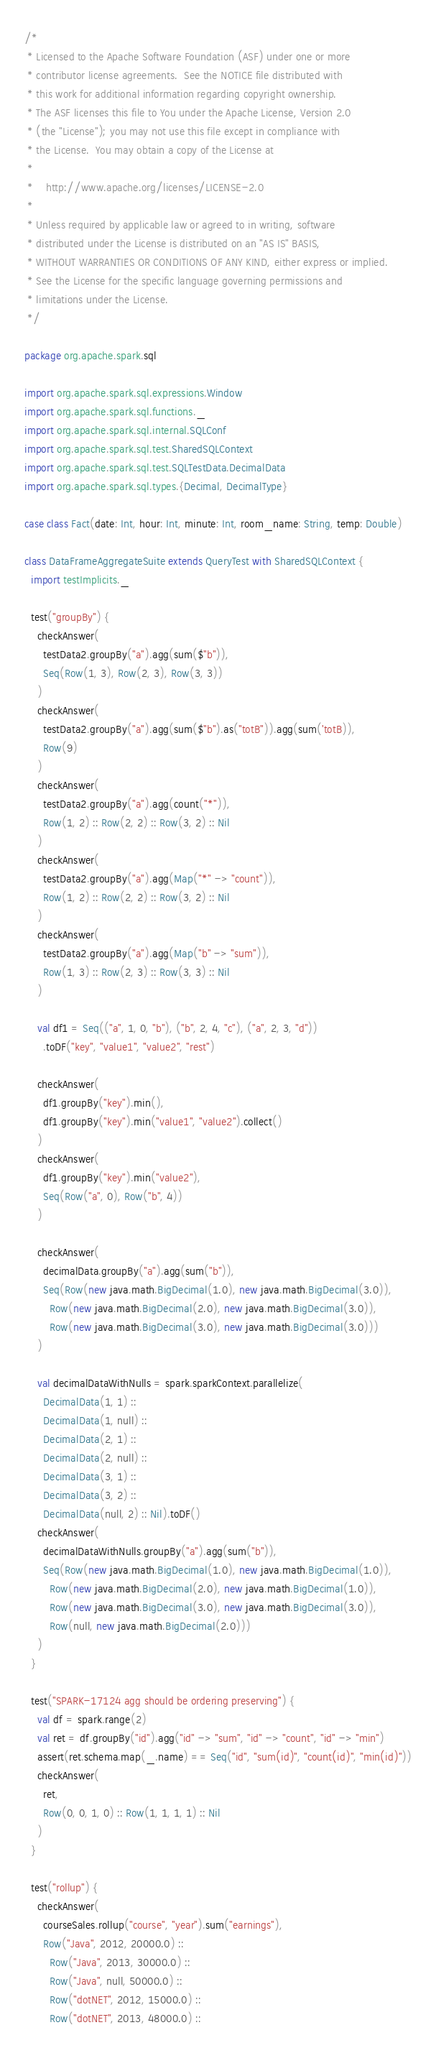<code> <loc_0><loc_0><loc_500><loc_500><_Scala_>/*
 * Licensed to the Apache Software Foundation (ASF) under one or more
 * contributor license agreements.  See the NOTICE file distributed with
 * this work for additional information regarding copyright ownership.
 * The ASF licenses this file to You under the Apache License, Version 2.0
 * (the "License"); you may not use this file except in compliance with
 * the License.  You may obtain a copy of the License at
 *
 *    http://www.apache.org/licenses/LICENSE-2.0
 *
 * Unless required by applicable law or agreed to in writing, software
 * distributed under the License is distributed on an "AS IS" BASIS,
 * WITHOUT WARRANTIES OR CONDITIONS OF ANY KIND, either express or implied.
 * See the License for the specific language governing permissions and
 * limitations under the License.
 */

package org.apache.spark.sql

import org.apache.spark.sql.expressions.Window
import org.apache.spark.sql.functions._
import org.apache.spark.sql.internal.SQLConf
import org.apache.spark.sql.test.SharedSQLContext
import org.apache.spark.sql.test.SQLTestData.DecimalData
import org.apache.spark.sql.types.{Decimal, DecimalType}

case class Fact(date: Int, hour: Int, minute: Int, room_name: String, temp: Double)

class DataFrameAggregateSuite extends QueryTest with SharedSQLContext {
  import testImplicits._

  test("groupBy") {
    checkAnswer(
      testData2.groupBy("a").agg(sum($"b")),
      Seq(Row(1, 3), Row(2, 3), Row(3, 3))
    )
    checkAnswer(
      testData2.groupBy("a").agg(sum($"b").as("totB")).agg(sum('totB)),
      Row(9)
    )
    checkAnswer(
      testData2.groupBy("a").agg(count("*")),
      Row(1, 2) :: Row(2, 2) :: Row(3, 2) :: Nil
    )
    checkAnswer(
      testData2.groupBy("a").agg(Map("*" -> "count")),
      Row(1, 2) :: Row(2, 2) :: Row(3, 2) :: Nil
    )
    checkAnswer(
      testData2.groupBy("a").agg(Map("b" -> "sum")),
      Row(1, 3) :: Row(2, 3) :: Row(3, 3) :: Nil
    )

    val df1 = Seq(("a", 1, 0, "b"), ("b", 2, 4, "c"), ("a", 2, 3, "d"))
      .toDF("key", "value1", "value2", "rest")

    checkAnswer(
      df1.groupBy("key").min(),
      df1.groupBy("key").min("value1", "value2").collect()
    )
    checkAnswer(
      df1.groupBy("key").min("value2"),
      Seq(Row("a", 0), Row("b", 4))
    )

    checkAnswer(
      decimalData.groupBy("a").agg(sum("b")),
      Seq(Row(new java.math.BigDecimal(1.0), new java.math.BigDecimal(3.0)),
        Row(new java.math.BigDecimal(2.0), new java.math.BigDecimal(3.0)),
        Row(new java.math.BigDecimal(3.0), new java.math.BigDecimal(3.0)))
    )

    val decimalDataWithNulls = spark.sparkContext.parallelize(
      DecimalData(1, 1) ::
      DecimalData(1, null) ::
      DecimalData(2, 1) ::
      DecimalData(2, null) ::
      DecimalData(3, 1) ::
      DecimalData(3, 2) ::
      DecimalData(null, 2) :: Nil).toDF()
    checkAnswer(
      decimalDataWithNulls.groupBy("a").agg(sum("b")),
      Seq(Row(new java.math.BigDecimal(1.0), new java.math.BigDecimal(1.0)),
        Row(new java.math.BigDecimal(2.0), new java.math.BigDecimal(1.0)),
        Row(new java.math.BigDecimal(3.0), new java.math.BigDecimal(3.0)),
        Row(null, new java.math.BigDecimal(2.0)))
    )
  }

  test("SPARK-17124 agg should be ordering preserving") {
    val df = spark.range(2)
    val ret = df.groupBy("id").agg("id" -> "sum", "id" -> "count", "id" -> "min")
    assert(ret.schema.map(_.name) == Seq("id", "sum(id)", "count(id)", "min(id)"))
    checkAnswer(
      ret,
      Row(0, 0, 1, 0) :: Row(1, 1, 1, 1) :: Nil
    )
  }

  test("rollup") {
    checkAnswer(
      courseSales.rollup("course", "year").sum("earnings"),
      Row("Java", 2012, 20000.0) ::
        Row("Java", 2013, 30000.0) ::
        Row("Java", null, 50000.0) ::
        Row("dotNET", 2012, 15000.0) ::
        Row("dotNET", 2013, 48000.0) ::</code> 